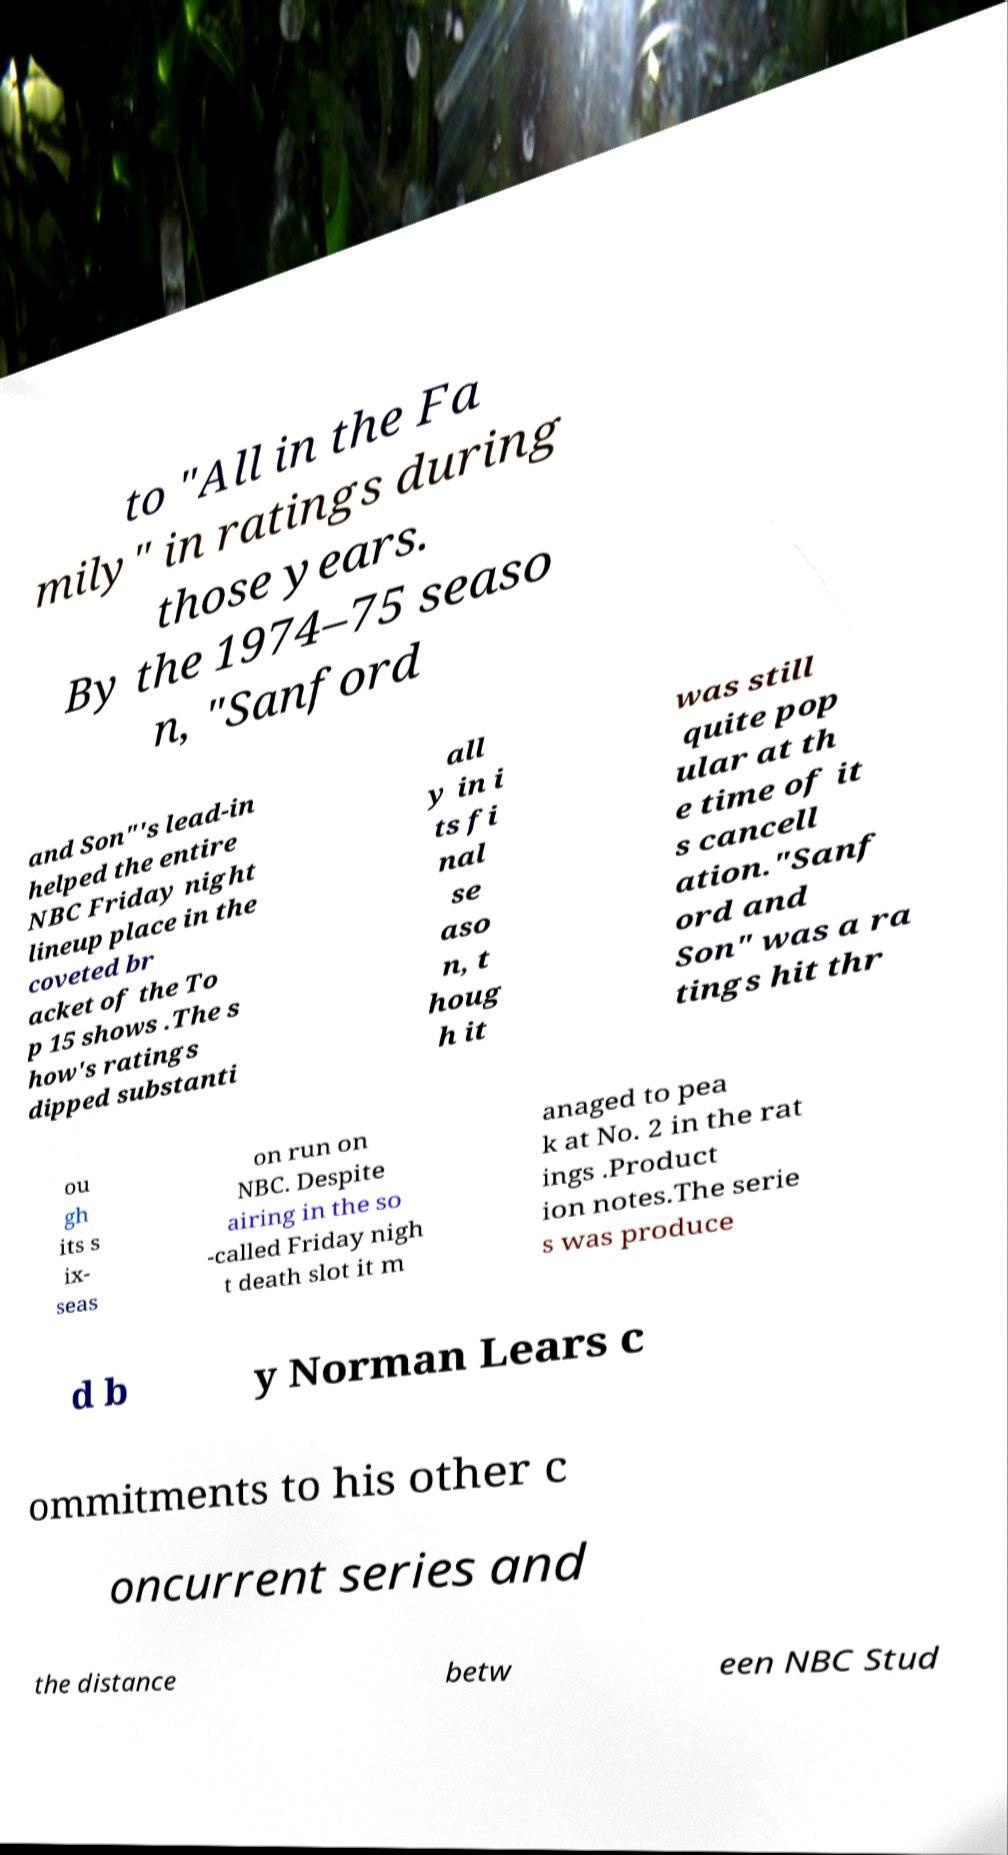What messages or text are displayed in this image? I need them in a readable, typed format. to "All in the Fa mily" in ratings during those years. By the 1974–75 seaso n, "Sanford and Son"'s lead-in helped the entire NBC Friday night lineup place in the coveted br acket of the To p 15 shows .The s how's ratings dipped substanti all y in i ts fi nal se aso n, t houg h it was still quite pop ular at th e time of it s cancell ation."Sanf ord and Son" was a ra tings hit thr ou gh its s ix- seas on run on NBC. Despite airing in the so -called Friday nigh t death slot it m anaged to pea k at No. 2 in the rat ings .Product ion notes.The serie s was produce d b y Norman Lears c ommitments to his other c oncurrent series and the distance betw een NBC Stud 